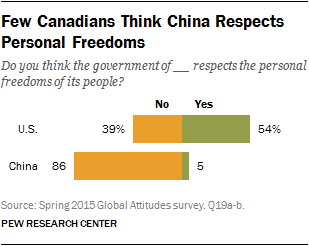Indicate a few pertinent items in this graphic. The average decision for the U.S. is 46.5. The two bars in the chart represent the answer to the question "What represents the two bars in the chart? [No, Yes]..". 